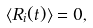<formula> <loc_0><loc_0><loc_500><loc_500>\langle R _ { i } ( t ) \rangle = 0 ,</formula> 